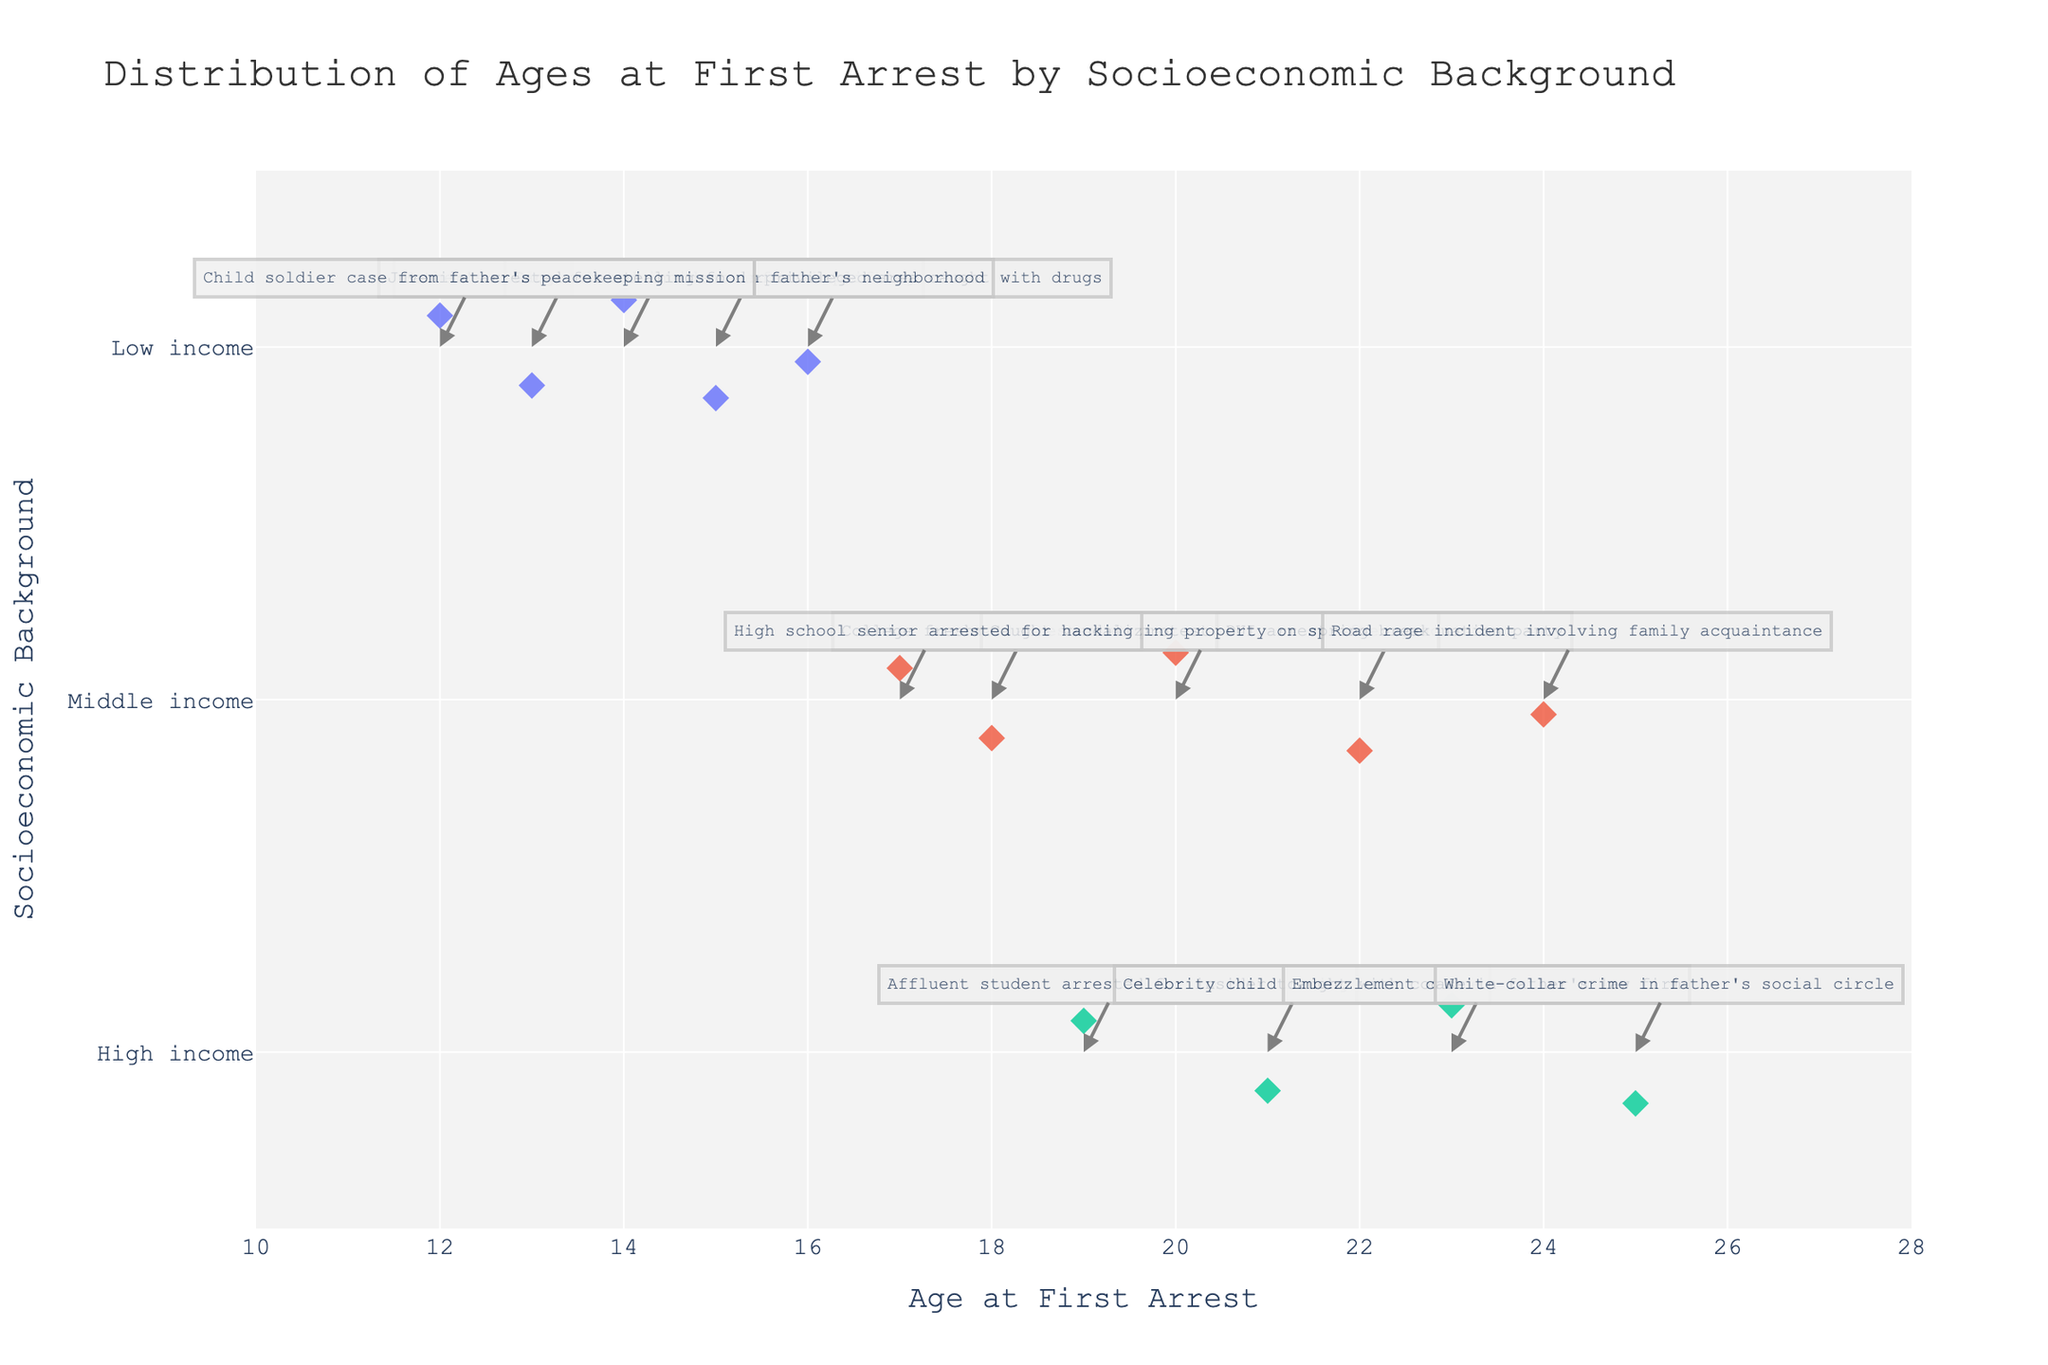Which socioeconomic background category shows the widest range of ages at first arrest? To determine this, look for the category with the largest spread between the youngest and oldest age at first arrest. From the plot, "High income" has arrests ranging from 19 to 25, "Middle income" from 17 to 24, and "Low income" from 12 to 16. The "Low income" category shows the widest range.
Answer: Low income What is the title of the strip plot? The title is usually displayed at the top of the plot, describing what the plot represents. In this case, it is "Distribution of Ages at First Arrest by Socioeconomic Background."
Answer: Distribution of Ages at First Arrest by Socioeconomic Background How many data points are there in the middle-income category? Count the number of points along the y-axis labeled "Middle income." There are 6 points.
Answer: 6 Which socioeconomic background has the oldest age at first arrest? Identify the highest age value on the x-axis and check which category it belongs to. The highest age is 25, which is in the "High income" category.
Answer: High income What is the median age at first arrest for the low-income category? First, list the ages for "Low income": 14, 16, 15, 13, 12. Then, order them in ascending order: 12, 13, 14, 15, 16. The median age, being the middle value, is 14.
Answer: 14 How does the age at first arrest for high-income individuals compare to low-income individuals? Compare the range of ages on the x-axis for both categories. "High income" ranges from 19 to 25, while "Low income" ranges from 12 to 16. High-income individuals tend to have their first arrest at a significantly older age than low-income individuals.
Answer: Older Which data point in the middle-income category has the most interesting anecdote related to property damage? Look at the hover data and annotations for the middle-income points. The anecdote "Caught vandalizing property on spring break" is related to property damage.
Answer: Caught vandalizing property on spring break What is the average age at first arrest across all categories? Add all the ages together and divide by the number of data points. The ages are: 14, 16, 15, 18, 22, 20, 19, 21, 23, 13, 17, 25, 12, 24. The total sum is 259, and there are 14 data points. Thus, the average is 259 / 14 = 18.5.
Answer: 18.5 Are there more incidents of first arrests before or after 18 years of age? Count the number of data points to the left (before) and right (after) of age 18 on the x-axis. There are 7 points before 18 and 7 points after 18.
Answer: Equal Which socioeconomic background has the highest variance in ages at first arrest? Variance measures how spread out the ages are. Visually check for the spread of points around the mean age of each category. "Low income" shows a larger spread of ages than "Middle income" and "High income," indicating higher variance.
Answer: Low income 